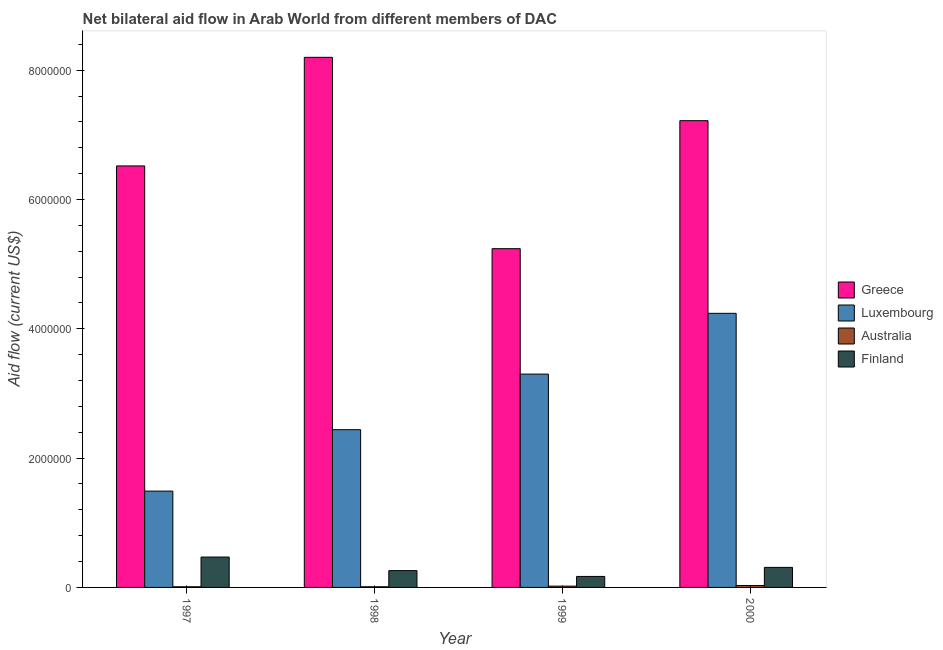How many different coloured bars are there?
Ensure brevity in your answer.  4. How many groups of bars are there?
Provide a short and direct response. 4. How many bars are there on the 1st tick from the left?
Keep it short and to the point. 4. In how many cases, is the number of bars for a given year not equal to the number of legend labels?
Keep it short and to the point. 0. What is the amount of aid given by australia in 2000?
Ensure brevity in your answer.  3.00e+04. Across all years, what is the maximum amount of aid given by australia?
Your answer should be compact. 3.00e+04. Across all years, what is the minimum amount of aid given by greece?
Your answer should be very brief. 5.24e+06. In which year was the amount of aid given by finland maximum?
Your answer should be very brief. 1997. What is the total amount of aid given by luxembourg in the graph?
Provide a succinct answer. 1.15e+07. What is the difference between the amount of aid given by luxembourg in 1997 and that in 1999?
Offer a very short reply. -1.81e+06. What is the difference between the amount of aid given by greece in 1997 and the amount of aid given by luxembourg in 1999?
Give a very brief answer. 1.28e+06. What is the average amount of aid given by greece per year?
Offer a very short reply. 6.80e+06. What is the ratio of the amount of aid given by finland in 1997 to that in 1998?
Give a very brief answer. 1.81. Is the amount of aid given by finland in 1997 less than that in 1998?
Provide a short and direct response. No. What is the difference between the highest and the second highest amount of aid given by australia?
Ensure brevity in your answer.  10000. What is the difference between the highest and the lowest amount of aid given by greece?
Provide a succinct answer. 2.96e+06. In how many years, is the amount of aid given by australia greater than the average amount of aid given by australia taken over all years?
Your answer should be compact. 2. Is the sum of the amount of aid given by australia in 1997 and 1999 greater than the maximum amount of aid given by finland across all years?
Provide a short and direct response. No. What is the difference between two consecutive major ticks on the Y-axis?
Your response must be concise. 2.00e+06. Does the graph contain any zero values?
Provide a succinct answer. No. Where does the legend appear in the graph?
Offer a terse response. Center right. How many legend labels are there?
Provide a succinct answer. 4. How are the legend labels stacked?
Keep it short and to the point. Vertical. What is the title of the graph?
Make the answer very short. Net bilateral aid flow in Arab World from different members of DAC. Does "Business regulatory environment" appear as one of the legend labels in the graph?
Keep it short and to the point. No. What is the label or title of the X-axis?
Provide a short and direct response. Year. What is the Aid flow (current US$) in Greece in 1997?
Your response must be concise. 6.52e+06. What is the Aid flow (current US$) in Luxembourg in 1997?
Offer a very short reply. 1.49e+06. What is the Aid flow (current US$) of Finland in 1997?
Your answer should be very brief. 4.70e+05. What is the Aid flow (current US$) of Greece in 1998?
Keep it short and to the point. 8.20e+06. What is the Aid flow (current US$) in Luxembourg in 1998?
Provide a short and direct response. 2.44e+06. What is the Aid flow (current US$) in Greece in 1999?
Ensure brevity in your answer.  5.24e+06. What is the Aid flow (current US$) of Luxembourg in 1999?
Give a very brief answer. 3.30e+06. What is the Aid flow (current US$) in Finland in 1999?
Your answer should be very brief. 1.70e+05. What is the Aid flow (current US$) in Greece in 2000?
Your response must be concise. 7.22e+06. What is the Aid flow (current US$) in Luxembourg in 2000?
Provide a short and direct response. 4.24e+06. What is the Aid flow (current US$) in Finland in 2000?
Your answer should be compact. 3.10e+05. Across all years, what is the maximum Aid flow (current US$) in Greece?
Ensure brevity in your answer.  8.20e+06. Across all years, what is the maximum Aid flow (current US$) of Luxembourg?
Your answer should be compact. 4.24e+06. Across all years, what is the maximum Aid flow (current US$) of Finland?
Your answer should be compact. 4.70e+05. Across all years, what is the minimum Aid flow (current US$) of Greece?
Your answer should be very brief. 5.24e+06. Across all years, what is the minimum Aid flow (current US$) of Luxembourg?
Provide a short and direct response. 1.49e+06. Across all years, what is the minimum Aid flow (current US$) of Australia?
Give a very brief answer. 10000. What is the total Aid flow (current US$) in Greece in the graph?
Provide a succinct answer. 2.72e+07. What is the total Aid flow (current US$) of Luxembourg in the graph?
Make the answer very short. 1.15e+07. What is the total Aid flow (current US$) in Finland in the graph?
Keep it short and to the point. 1.21e+06. What is the difference between the Aid flow (current US$) in Greece in 1997 and that in 1998?
Your answer should be very brief. -1.68e+06. What is the difference between the Aid flow (current US$) of Luxembourg in 1997 and that in 1998?
Your answer should be very brief. -9.50e+05. What is the difference between the Aid flow (current US$) in Australia in 1997 and that in 1998?
Provide a short and direct response. 0. What is the difference between the Aid flow (current US$) of Greece in 1997 and that in 1999?
Give a very brief answer. 1.28e+06. What is the difference between the Aid flow (current US$) of Luxembourg in 1997 and that in 1999?
Keep it short and to the point. -1.81e+06. What is the difference between the Aid flow (current US$) of Australia in 1997 and that in 1999?
Make the answer very short. -10000. What is the difference between the Aid flow (current US$) in Finland in 1997 and that in 1999?
Offer a very short reply. 3.00e+05. What is the difference between the Aid flow (current US$) in Greece in 1997 and that in 2000?
Provide a short and direct response. -7.00e+05. What is the difference between the Aid flow (current US$) of Luxembourg in 1997 and that in 2000?
Ensure brevity in your answer.  -2.75e+06. What is the difference between the Aid flow (current US$) in Australia in 1997 and that in 2000?
Give a very brief answer. -2.00e+04. What is the difference between the Aid flow (current US$) in Finland in 1997 and that in 2000?
Provide a short and direct response. 1.60e+05. What is the difference between the Aid flow (current US$) in Greece in 1998 and that in 1999?
Give a very brief answer. 2.96e+06. What is the difference between the Aid flow (current US$) of Luxembourg in 1998 and that in 1999?
Your answer should be very brief. -8.60e+05. What is the difference between the Aid flow (current US$) in Greece in 1998 and that in 2000?
Your response must be concise. 9.80e+05. What is the difference between the Aid flow (current US$) of Luxembourg in 1998 and that in 2000?
Your answer should be very brief. -1.80e+06. What is the difference between the Aid flow (current US$) in Finland in 1998 and that in 2000?
Your answer should be compact. -5.00e+04. What is the difference between the Aid flow (current US$) in Greece in 1999 and that in 2000?
Ensure brevity in your answer.  -1.98e+06. What is the difference between the Aid flow (current US$) in Luxembourg in 1999 and that in 2000?
Provide a succinct answer. -9.40e+05. What is the difference between the Aid flow (current US$) in Australia in 1999 and that in 2000?
Provide a short and direct response. -10000. What is the difference between the Aid flow (current US$) of Finland in 1999 and that in 2000?
Ensure brevity in your answer.  -1.40e+05. What is the difference between the Aid flow (current US$) in Greece in 1997 and the Aid flow (current US$) in Luxembourg in 1998?
Provide a short and direct response. 4.08e+06. What is the difference between the Aid flow (current US$) of Greece in 1997 and the Aid flow (current US$) of Australia in 1998?
Make the answer very short. 6.51e+06. What is the difference between the Aid flow (current US$) in Greece in 1997 and the Aid flow (current US$) in Finland in 1998?
Make the answer very short. 6.26e+06. What is the difference between the Aid flow (current US$) of Luxembourg in 1997 and the Aid flow (current US$) of Australia in 1998?
Make the answer very short. 1.48e+06. What is the difference between the Aid flow (current US$) in Luxembourg in 1997 and the Aid flow (current US$) in Finland in 1998?
Your answer should be compact. 1.23e+06. What is the difference between the Aid flow (current US$) in Australia in 1997 and the Aid flow (current US$) in Finland in 1998?
Your answer should be very brief. -2.50e+05. What is the difference between the Aid flow (current US$) in Greece in 1997 and the Aid flow (current US$) in Luxembourg in 1999?
Give a very brief answer. 3.22e+06. What is the difference between the Aid flow (current US$) in Greece in 1997 and the Aid flow (current US$) in Australia in 1999?
Provide a short and direct response. 6.50e+06. What is the difference between the Aid flow (current US$) in Greece in 1997 and the Aid flow (current US$) in Finland in 1999?
Keep it short and to the point. 6.35e+06. What is the difference between the Aid flow (current US$) in Luxembourg in 1997 and the Aid flow (current US$) in Australia in 1999?
Your answer should be compact. 1.47e+06. What is the difference between the Aid flow (current US$) in Luxembourg in 1997 and the Aid flow (current US$) in Finland in 1999?
Give a very brief answer. 1.32e+06. What is the difference between the Aid flow (current US$) in Greece in 1997 and the Aid flow (current US$) in Luxembourg in 2000?
Offer a terse response. 2.28e+06. What is the difference between the Aid flow (current US$) in Greece in 1997 and the Aid flow (current US$) in Australia in 2000?
Your answer should be very brief. 6.49e+06. What is the difference between the Aid flow (current US$) of Greece in 1997 and the Aid flow (current US$) of Finland in 2000?
Your answer should be compact. 6.21e+06. What is the difference between the Aid flow (current US$) of Luxembourg in 1997 and the Aid flow (current US$) of Australia in 2000?
Offer a very short reply. 1.46e+06. What is the difference between the Aid flow (current US$) in Luxembourg in 1997 and the Aid flow (current US$) in Finland in 2000?
Your answer should be compact. 1.18e+06. What is the difference between the Aid flow (current US$) in Australia in 1997 and the Aid flow (current US$) in Finland in 2000?
Your answer should be compact. -3.00e+05. What is the difference between the Aid flow (current US$) in Greece in 1998 and the Aid flow (current US$) in Luxembourg in 1999?
Make the answer very short. 4.90e+06. What is the difference between the Aid flow (current US$) in Greece in 1998 and the Aid flow (current US$) in Australia in 1999?
Keep it short and to the point. 8.18e+06. What is the difference between the Aid flow (current US$) of Greece in 1998 and the Aid flow (current US$) of Finland in 1999?
Your answer should be very brief. 8.03e+06. What is the difference between the Aid flow (current US$) in Luxembourg in 1998 and the Aid flow (current US$) in Australia in 1999?
Make the answer very short. 2.42e+06. What is the difference between the Aid flow (current US$) of Luxembourg in 1998 and the Aid flow (current US$) of Finland in 1999?
Keep it short and to the point. 2.27e+06. What is the difference between the Aid flow (current US$) in Greece in 1998 and the Aid flow (current US$) in Luxembourg in 2000?
Make the answer very short. 3.96e+06. What is the difference between the Aid flow (current US$) of Greece in 1998 and the Aid flow (current US$) of Australia in 2000?
Your answer should be very brief. 8.17e+06. What is the difference between the Aid flow (current US$) in Greece in 1998 and the Aid flow (current US$) in Finland in 2000?
Make the answer very short. 7.89e+06. What is the difference between the Aid flow (current US$) of Luxembourg in 1998 and the Aid flow (current US$) of Australia in 2000?
Provide a succinct answer. 2.41e+06. What is the difference between the Aid flow (current US$) in Luxembourg in 1998 and the Aid flow (current US$) in Finland in 2000?
Your answer should be compact. 2.13e+06. What is the difference between the Aid flow (current US$) of Greece in 1999 and the Aid flow (current US$) of Australia in 2000?
Keep it short and to the point. 5.21e+06. What is the difference between the Aid flow (current US$) in Greece in 1999 and the Aid flow (current US$) in Finland in 2000?
Provide a short and direct response. 4.93e+06. What is the difference between the Aid flow (current US$) in Luxembourg in 1999 and the Aid flow (current US$) in Australia in 2000?
Your answer should be very brief. 3.27e+06. What is the difference between the Aid flow (current US$) in Luxembourg in 1999 and the Aid flow (current US$) in Finland in 2000?
Make the answer very short. 2.99e+06. What is the average Aid flow (current US$) in Greece per year?
Give a very brief answer. 6.80e+06. What is the average Aid flow (current US$) of Luxembourg per year?
Provide a succinct answer. 2.87e+06. What is the average Aid flow (current US$) of Australia per year?
Give a very brief answer. 1.75e+04. What is the average Aid flow (current US$) in Finland per year?
Provide a short and direct response. 3.02e+05. In the year 1997, what is the difference between the Aid flow (current US$) in Greece and Aid flow (current US$) in Luxembourg?
Your answer should be very brief. 5.03e+06. In the year 1997, what is the difference between the Aid flow (current US$) of Greece and Aid flow (current US$) of Australia?
Make the answer very short. 6.51e+06. In the year 1997, what is the difference between the Aid flow (current US$) in Greece and Aid flow (current US$) in Finland?
Ensure brevity in your answer.  6.05e+06. In the year 1997, what is the difference between the Aid flow (current US$) in Luxembourg and Aid flow (current US$) in Australia?
Make the answer very short. 1.48e+06. In the year 1997, what is the difference between the Aid flow (current US$) of Luxembourg and Aid flow (current US$) of Finland?
Provide a short and direct response. 1.02e+06. In the year 1997, what is the difference between the Aid flow (current US$) in Australia and Aid flow (current US$) in Finland?
Your response must be concise. -4.60e+05. In the year 1998, what is the difference between the Aid flow (current US$) in Greece and Aid flow (current US$) in Luxembourg?
Your answer should be very brief. 5.76e+06. In the year 1998, what is the difference between the Aid flow (current US$) of Greece and Aid flow (current US$) of Australia?
Offer a terse response. 8.19e+06. In the year 1998, what is the difference between the Aid flow (current US$) in Greece and Aid flow (current US$) in Finland?
Provide a short and direct response. 7.94e+06. In the year 1998, what is the difference between the Aid flow (current US$) in Luxembourg and Aid flow (current US$) in Australia?
Keep it short and to the point. 2.43e+06. In the year 1998, what is the difference between the Aid flow (current US$) of Luxembourg and Aid flow (current US$) of Finland?
Provide a short and direct response. 2.18e+06. In the year 1998, what is the difference between the Aid flow (current US$) of Australia and Aid flow (current US$) of Finland?
Keep it short and to the point. -2.50e+05. In the year 1999, what is the difference between the Aid flow (current US$) of Greece and Aid flow (current US$) of Luxembourg?
Give a very brief answer. 1.94e+06. In the year 1999, what is the difference between the Aid flow (current US$) of Greece and Aid flow (current US$) of Australia?
Offer a terse response. 5.22e+06. In the year 1999, what is the difference between the Aid flow (current US$) in Greece and Aid flow (current US$) in Finland?
Your response must be concise. 5.07e+06. In the year 1999, what is the difference between the Aid flow (current US$) of Luxembourg and Aid flow (current US$) of Australia?
Your answer should be compact. 3.28e+06. In the year 1999, what is the difference between the Aid flow (current US$) in Luxembourg and Aid flow (current US$) in Finland?
Your answer should be very brief. 3.13e+06. In the year 2000, what is the difference between the Aid flow (current US$) in Greece and Aid flow (current US$) in Luxembourg?
Your answer should be very brief. 2.98e+06. In the year 2000, what is the difference between the Aid flow (current US$) in Greece and Aid flow (current US$) in Australia?
Your answer should be compact. 7.19e+06. In the year 2000, what is the difference between the Aid flow (current US$) in Greece and Aid flow (current US$) in Finland?
Make the answer very short. 6.91e+06. In the year 2000, what is the difference between the Aid flow (current US$) of Luxembourg and Aid flow (current US$) of Australia?
Keep it short and to the point. 4.21e+06. In the year 2000, what is the difference between the Aid flow (current US$) of Luxembourg and Aid flow (current US$) of Finland?
Provide a succinct answer. 3.93e+06. In the year 2000, what is the difference between the Aid flow (current US$) in Australia and Aid flow (current US$) in Finland?
Your answer should be very brief. -2.80e+05. What is the ratio of the Aid flow (current US$) in Greece in 1997 to that in 1998?
Provide a succinct answer. 0.8. What is the ratio of the Aid flow (current US$) in Luxembourg in 1997 to that in 1998?
Provide a succinct answer. 0.61. What is the ratio of the Aid flow (current US$) in Finland in 1997 to that in 1998?
Your answer should be compact. 1.81. What is the ratio of the Aid flow (current US$) in Greece in 1997 to that in 1999?
Offer a terse response. 1.24. What is the ratio of the Aid flow (current US$) in Luxembourg in 1997 to that in 1999?
Your answer should be very brief. 0.45. What is the ratio of the Aid flow (current US$) in Australia in 1997 to that in 1999?
Make the answer very short. 0.5. What is the ratio of the Aid flow (current US$) of Finland in 1997 to that in 1999?
Your response must be concise. 2.76. What is the ratio of the Aid flow (current US$) of Greece in 1997 to that in 2000?
Provide a succinct answer. 0.9. What is the ratio of the Aid flow (current US$) in Luxembourg in 1997 to that in 2000?
Your response must be concise. 0.35. What is the ratio of the Aid flow (current US$) of Finland in 1997 to that in 2000?
Keep it short and to the point. 1.52. What is the ratio of the Aid flow (current US$) of Greece in 1998 to that in 1999?
Offer a very short reply. 1.56. What is the ratio of the Aid flow (current US$) in Luxembourg in 1998 to that in 1999?
Provide a short and direct response. 0.74. What is the ratio of the Aid flow (current US$) in Australia in 1998 to that in 1999?
Keep it short and to the point. 0.5. What is the ratio of the Aid flow (current US$) of Finland in 1998 to that in 1999?
Offer a very short reply. 1.53. What is the ratio of the Aid flow (current US$) of Greece in 1998 to that in 2000?
Offer a terse response. 1.14. What is the ratio of the Aid flow (current US$) of Luxembourg in 1998 to that in 2000?
Your answer should be very brief. 0.58. What is the ratio of the Aid flow (current US$) of Australia in 1998 to that in 2000?
Make the answer very short. 0.33. What is the ratio of the Aid flow (current US$) in Finland in 1998 to that in 2000?
Keep it short and to the point. 0.84. What is the ratio of the Aid flow (current US$) in Greece in 1999 to that in 2000?
Offer a terse response. 0.73. What is the ratio of the Aid flow (current US$) in Luxembourg in 1999 to that in 2000?
Your answer should be compact. 0.78. What is the ratio of the Aid flow (current US$) of Australia in 1999 to that in 2000?
Your answer should be compact. 0.67. What is the ratio of the Aid flow (current US$) in Finland in 1999 to that in 2000?
Your answer should be very brief. 0.55. What is the difference between the highest and the second highest Aid flow (current US$) of Greece?
Offer a very short reply. 9.80e+05. What is the difference between the highest and the second highest Aid flow (current US$) in Luxembourg?
Give a very brief answer. 9.40e+05. What is the difference between the highest and the second highest Aid flow (current US$) in Finland?
Offer a terse response. 1.60e+05. What is the difference between the highest and the lowest Aid flow (current US$) of Greece?
Give a very brief answer. 2.96e+06. What is the difference between the highest and the lowest Aid flow (current US$) of Luxembourg?
Ensure brevity in your answer.  2.75e+06. What is the difference between the highest and the lowest Aid flow (current US$) of Finland?
Make the answer very short. 3.00e+05. 